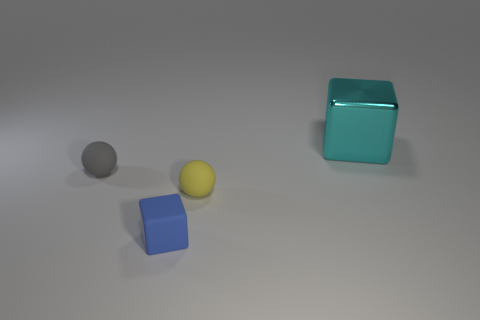Add 1 small blue matte things. How many objects exist? 5 Subtract 0 red cylinders. How many objects are left? 4 Subtract all cyan shiny objects. Subtract all big cyan things. How many objects are left? 2 Add 3 small spheres. How many small spheres are left? 5 Add 4 small matte things. How many small matte things exist? 7 